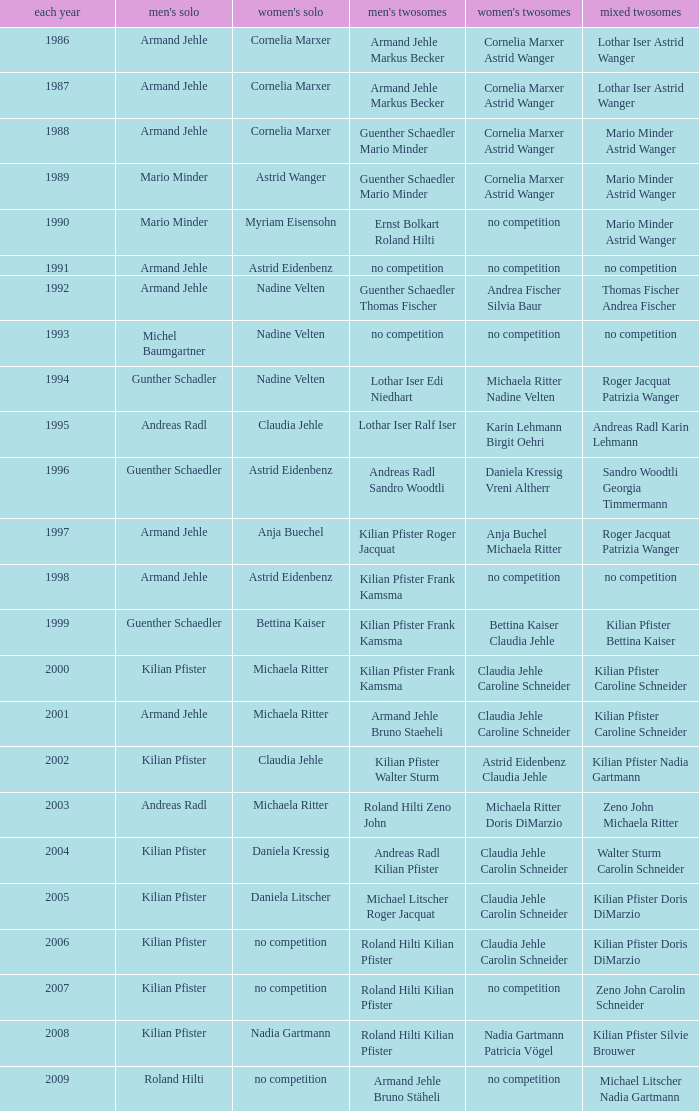What is the most current year where the women's doubles champions are astrid eidenbenz claudia jehle 2002.0. 